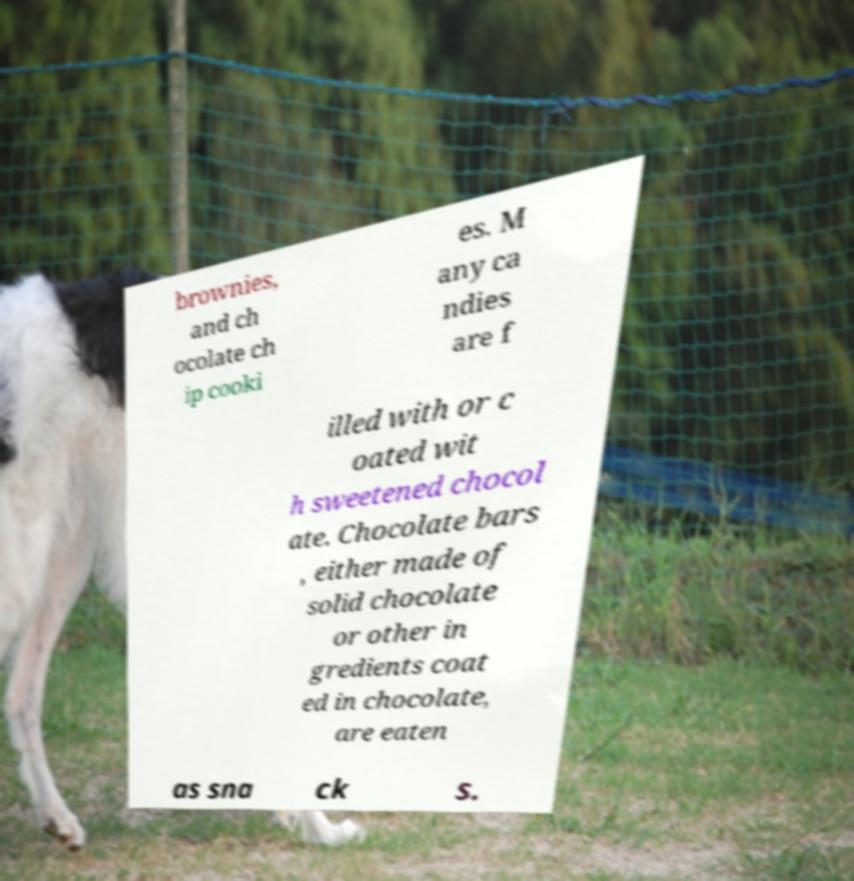Please identify and transcribe the text found in this image. brownies, and ch ocolate ch ip cooki es. M any ca ndies are f illed with or c oated wit h sweetened chocol ate. Chocolate bars , either made of solid chocolate or other in gredients coat ed in chocolate, are eaten as sna ck s. 